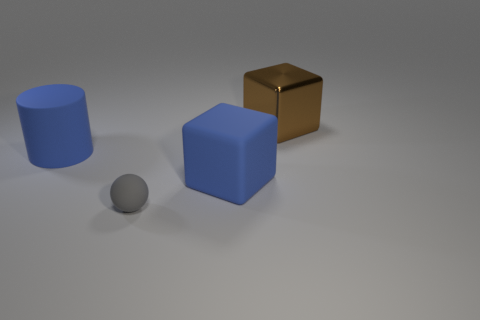Add 3 large blue matte things. How many objects exist? 7 Subtract all cylinders. How many objects are left? 3 Subtract all gray metallic cylinders. Subtract all small gray things. How many objects are left? 3 Add 1 brown metallic cubes. How many brown metallic cubes are left? 2 Add 4 large rubber cylinders. How many large rubber cylinders exist? 5 Subtract 0 green cylinders. How many objects are left? 4 